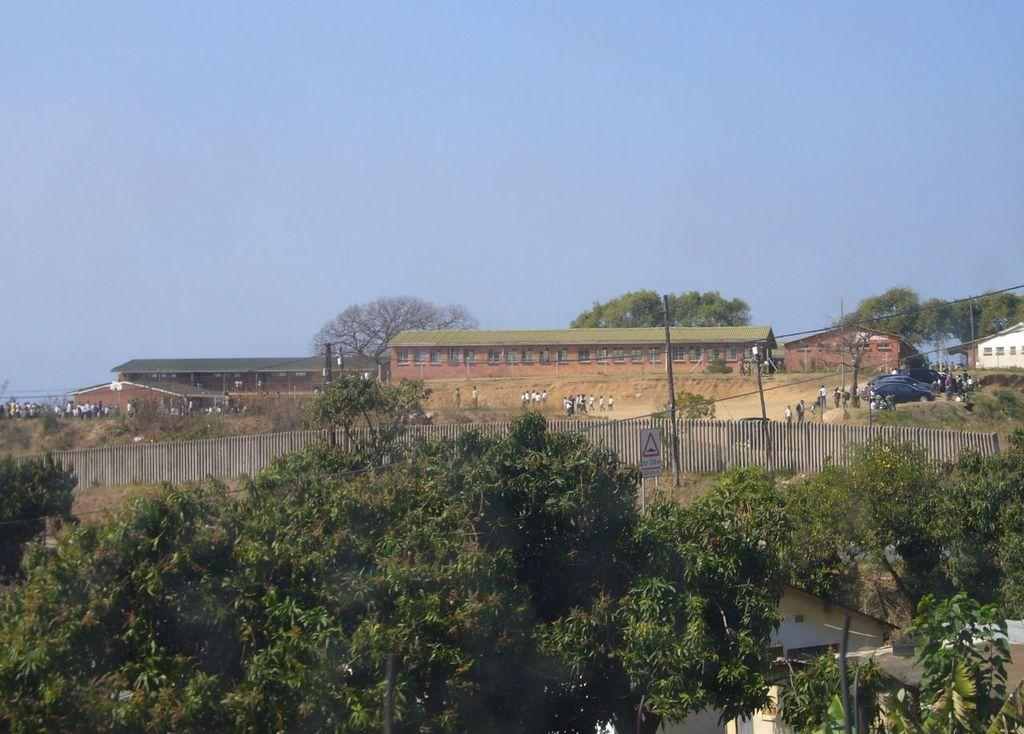What type of natural elements can be seen in the image? There are trees and water visible in the image. What type of man-made structures can be seen in the image? There is fencing, a name board, poles, vehicles, buildings, and a group of people visible in the image. What is visible in the background of the image? The sky is visible in the background of the image. Can you see a rifle in the image? No, there is no rifle present in the image. Is anyone wearing a veil in the image? No, there is no veil present in the image. 